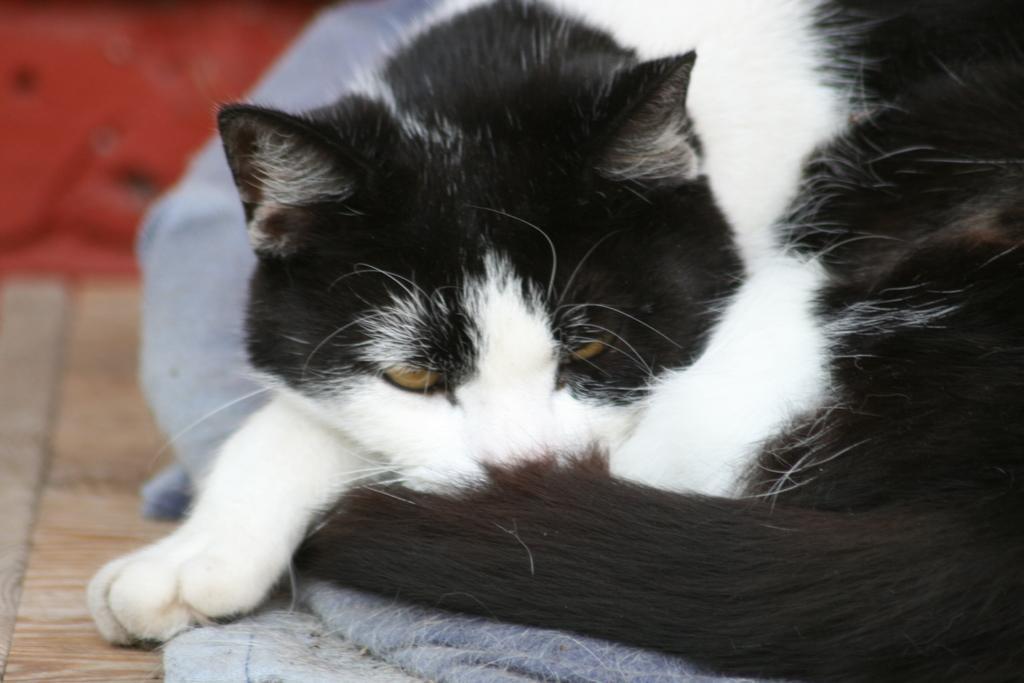In one or two sentences, can you explain what this image depicts? This image is taken indoors. At the bottom of the image there is a floor. On the right side of the image there is a cat on the towel. In the background there is a wall. 